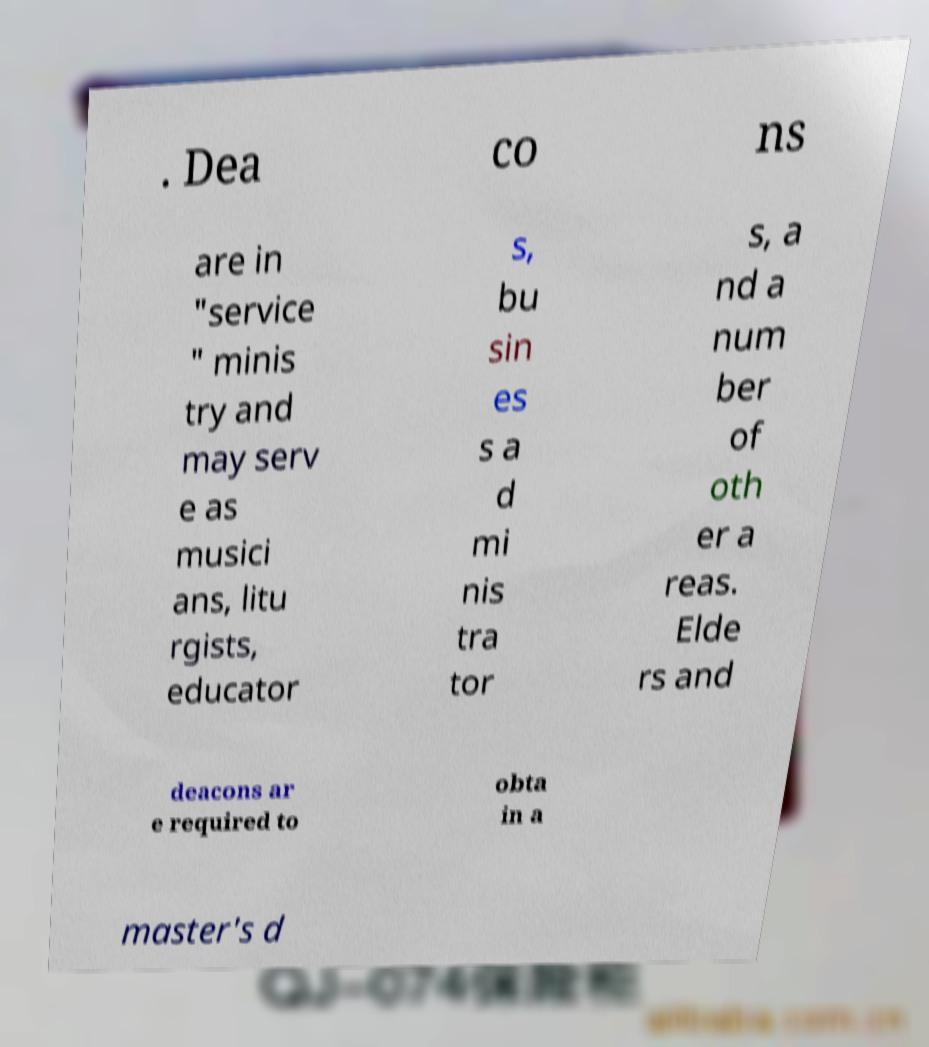Can you read and provide the text displayed in the image?This photo seems to have some interesting text. Can you extract and type it out for me? . Dea co ns are in "service " minis try and may serv e as musici ans, litu rgists, educator s, bu sin es s a d mi nis tra tor s, a nd a num ber of oth er a reas. Elde rs and deacons ar e required to obta in a master's d 